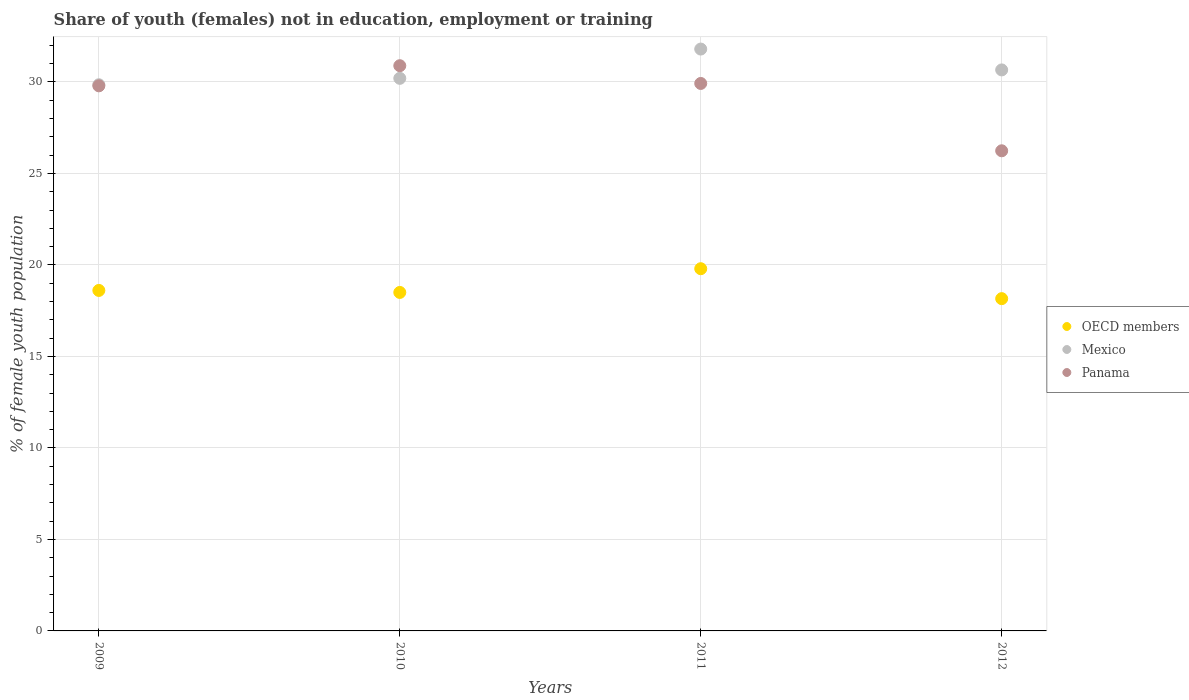Is the number of dotlines equal to the number of legend labels?
Offer a very short reply. Yes. What is the percentage of unemployed female population in in Mexico in 2012?
Provide a short and direct response. 30.66. Across all years, what is the maximum percentage of unemployed female population in in OECD members?
Your answer should be compact. 19.8. Across all years, what is the minimum percentage of unemployed female population in in Mexico?
Your answer should be compact. 29.85. In which year was the percentage of unemployed female population in in Mexico maximum?
Offer a very short reply. 2011. What is the total percentage of unemployed female population in in Panama in the graph?
Your answer should be very brief. 116.84. What is the difference between the percentage of unemployed female population in in Mexico in 2009 and that in 2011?
Offer a very short reply. -1.95. What is the difference between the percentage of unemployed female population in in Panama in 2009 and the percentage of unemployed female population in in Mexico in 2010?
Give a very brief answer. -0.41. What is the average percentage of unemployed female population in in OECD members per year?
Make the answer very short. 18.77. In the year 2010, what is the difference between the percentage of unemployed female population in in Mexico and percentage of unemployed female population in in OECD members?
Your answer should be compact. 11.7. What is the ratio of the percentage of unemployed female population in in OECD members in 2009 to that in 2011?
Ensure brevity in your answer.  0.94. Is the percentage of unemployed female population in in OECD members in 2009 less than that in 2012?
Ensure brevity in your answer.  No. What is the difference between the highest and the second highest percentage of unemployed female population in in Panama?
Offer a very short reply. 0.97. What is the difference between the highest and the lowest percentage of unemployed female population in in Mexico?
Offer a very short reply. 1.95. How many dotlines are there?
Your answer should be compact. 3. What is the difference between two consecutive major ticks on the Y-axis?
Your response must be concise. 5. Are the values on the major ticks of Y-axis written in scientific E-notation?
Make the answer very short. No. Where does the legend appear in the graph?
Your answer should be compact. Center right. What is the title of the graph?
Make the answer very short. Share of youth (females) not in education, employment or training. Does "Qatar" appear as one of the legend labels in the graph?
Provide a short and direct response. No. What is the label or title of the Y-axis?
Ensure brevity in your answer.  % of female youth population. What is the % of female youth population in OECD members in 2009?
Ensure brevity in your answer.  18.61. What is the % of female youth population in Mexico in 2009?
Your answer should be very brief. 29.85. What is the % of female youth population in Panama in 2009?
Give a very brief answer. 29.79. What is the % of female youth population of OECD members in 2010?
Offer a terse response. 18.5. What is the % of female youth population of Mexico in 2010?
Keep it short and to the point. 30.2. What is the % of female youth population in Panama in 2010?
Your answer should be compact. 30.89. What is the % of female youth population in OECD members in 2011?
Provide a succinct answer. 19.8. What is the % of female youth population in Mexico in 2011?
Provide a short and direct response. 31.8. What is the % of female youth population of Panama in 2011?
Offer a very short reply. 29.92. What is the % of female youth population in OECD members in 2012?
Provide a short and direct response. 18.16. What is the % of female youth population in Mexico in 2012?
Provide a short and direct response. 30.66. What is the % of female youth population of Panama in 2012?
Offer a very short reply. 26.24. Across all years, what is the maximum % of female youth population of OECD members?
Your answer should be compact. 19.8. Across all years, what is the maximum % of female youth population of Mexico?
Your answer should be compact. 31.8. Across all years, what is the maximum % of female youth population of Panama?
Your answer should be very brief. 30.89. Across all years, what is the minimum % of female youth population in OECD members?
Offer a terse response. 18.16. Across all years, what is the minimum % of female youth population of Mexico?
Your answer should be very brief. 29.85. Across all years, what is the minimum % of female youth population in Panama?
Your answer should be compact. 26.24. What is the total % of female youth population of OECD members in the graph?
Make the answer very short. 75.06. What is the total % of female youth population of Mexico in the graph?
Ensure brevity in your answer.  122.51. What is the total % of female youth population in Panama in the graph?
Offer a terse response. 116.84. What is the difference between the % of female youth population of OECD members in 2009 and that in 2010?
Offer a very short reply. 0.11. What is the difference between the % of female youth population of Mexico in 2009 and that in 2010?
Provide a succinct answer. -0.35. What is the difference between the % of female youth population of OECD members in 2009 and that in 2011?
Your answer should be compact. -1.19. What is the difference between the % of female youth population of Mexico in 2009 and that in 2011?
Your response must be concise. -1.95. What is the difference between the % of female youth population of Panama in 2009 and that in 2011?
Make the answer very short. -0.13. What is the difference between the % of female youth population of OECD members in 2009 and that in 2012?
Ensure brevity in your answer.  0.45. What is the difference between the % of female youth population of Mexico in 2009 and that in 2012?
Give a very brief answer. -0.81. What is the difference between the % of female youth population in Panama in 2009 and that in 2012?
Make the answer very short. 3.55. What is the difference between the % of female youth population of OECD members in 2010 and that in 2011?
Your answer should be compact. -1.3. What is the difference between the % of female youth population of OECD members in 2010 and that in 2012?
Keep it short and to the point. 0.34. What is the difference between the % of female youth population of Mexico in 2010 and that in 2012?
Give a very brief answer. -0.46. What is the difference between the % of female youth population of Panama in 2010 and that in 2012?
Make the answer very short. 4.65. What is the difference between the % of female youth population of OECD members in 2011 and that in 2012?
Offer a very short reply. 1.64. What is the difference between the % of female youth population of Mexico in 2011 and that in 2012?
Your answer should be very brief. 1.14. What is the difference between the % of female youth population of Panama in 2011 and that in 2012?
Keep it short and to the point. 3.68. What is the difference between the % of female youth population of OECD members in 2009 and the % of female youth population of Mexico in 2010?
Your answer should be very brief. -11.59. What is the difference between the % of female youth population of OECD members in 2009 and the % of female youth population of Panama in 2010?
Your answer should be very brief. -12.28. What is the difference between the % of female youth population of Mexico in 2009 and the % of female youth population of Panama in 2010?
Your answer should be compact. -1.04. What is the difference between the % of female youth population in OECD members in 2009 and the % of female youth population in Mexico in 2011?
Ensure brevity in your answer.  -13.19. What is the difference between the % of female youth population in OECD members in 2009 and the % of female youth population in Panama in 2011?
Your response must be concise. -11.31. What is the difference between the % of female youth population in Mexico in 2009 and the % of female youth population in Panama in 2011?
Give a very brief answer. -0.07. What is the difference between the % of female youth population in OECD members in 2009 and the % of female youth population in Mexico in 2012?
Your response must be concise. -12.05. What is the difference between the % of female youth population in OECD members in 2009 and the % of female youth population in Panama in 2012?
Keep it short and to the point. -7.63. What is the difference between the % of female youth population in Mexico in 2009 and the % of female youth population in Panama in 2012?
Your answer should be compact. 3.61. What is the difference between the % of female youth population of OECD members in 2010 and the % of female youth population of Mexico in 2011?
Provide a short and direct response. -13.3. What is the difference between the % of female youth population in OECD members in 2010 and the % of female youth population in Panama in 2011?
Give a very brief answer. -11.42. What is the difference between the % of female youth population in Mexico in 2010 and the % of female youth population in Panama in 2011?
Provide a short and direct response. 0.28. What is the difference between the % of female youth population of OECD members in 2010 and the % of female youth population of Mexico in 2012?
Offer a terse response. -12.16. What is the difference between the % of female youth population of OECD members in 2010 and the % of female youth population of Panama in 2012?
Give a very brief answer. -7.74. What is the difference between the % of female youth population in Mexico in 2010 and the % of female youth population in Panama in 2012?
Provide a succinct answer. 3.96. What is the difference between the % of female youth population of OECD members in 2011 and the % of female youth population of Mexico in 2012?
Offer a terse response. -10.86. What is the difference between the % of female youth population of OECD members in 2011 and the % of female youth population of Panama in 2012?
Offer a terse response. -6.44. What is the difference between the % of female youth population in Mexico in 2011 and the % of female youth population in Panama in 2012?
Give a very brief answer. 5.56. What is the average % of female youth population in OECD members per year?
Offer a terse response. 18.77. What is the average % of female youth population of Mexico per year?
Give a very brief answer. 30.63. What is the average % of female youth population in Panama per year?
Make the answer very short. 29.21. In the year 2009, what is the difference between the % of female youth population in OECD members and % of female youth population in Mexico?
Your answer should be compact. -11.24. In the year 2009, what is the difference between the % of female youth population of OECD members and % of female youth population of Panama?
Your answer should be very brief. -11.18. In the year 2010, what is the difference between the % of female youth population in OECD members and % of female youth population in Mexico?
Offer a very short reply. -11.7. In the year 2010, what is the difference between the % of female youth population in OECD members and % of female youth population in Panama?
Your answer should be very brief. -12.39. In the year 2010, what is the difference between the % of female youth population of Mexico and % of female youth population of Panama?
Your response must be concise. -0.69. In the year 2011, what is the difference between the % of female youth population in OECD members and % of female youth population in Mexico?
Provide a succinct answer. -12. In the year 2011, what is the difference between the % of female youth population in OECD members and % of female youth population in Panama?
Offer a very short reply. -10.12. In the year 2011, what is the difference between the % of female youth population in Mexico and % of female youth population in Panama?
Keep it short and to the point. 1.88. In the year 2012, what is the difference between the % of female youth population in OECD members and % of female youth population in Mexico?
Give a very brief answer. -12.5. In the year 2012, what is the difference between the % of female youth population of OECD members and % of female youth population of Panama?
Your answer should be compact. -8.08. In the year 2012, what is the difference between the % of female youth population of Mexico and % of female youth population of Panama?
Provide a succinct answer. 4.42. What is the ratio of the % of female youth population in OECD members in 2009 to that in 2010?
Provide a short and direct response. 1.01. What is the ratio of the % of female youth population of Mexico in 2009 to that in 2010?
Provide a succinct answer. 0.99. What is the ratio of the % of female youth population in Panama in 2009 to that in 2010?
Your answer should be compact. 0.96. What is the ratio of the % of female youth population in OECD members in 2009 to that in 2011?
Your answer should be compact. 0.94. What is the ratio of the % of female youth population in Mexico in 2009 to that in 2011?
Your answer should be very brief. 0.94. What is the ratio of the % of female youth population in OECD members in 2009 to that in 2012?
Ensure brevity in your answer.  1.02. What is the ratio of the % of female youth population of Mexico in 2009 to that in 2012?
Keep it short and to the point. 0.97. What is the ratio of the % of female youth population in Panama in 2009 to that in 2012?
Give a very brief answer. 1.14. What is the ratio of the % of female youth population of OECD members in 2010 to that in 2011?
Give a very brief answer. 0.93. What is the ratio of the % of female youth population of Mexico in 2010 to that in 2011?
Give a very brief answer. 0.95. What is the ratio of the % of female youth population in Panama in 2010 to that in 2011?
Your answer should be compact. 1.03. What is the ratio of the % of female youth population of OECD members in 2010 to that in 2012?
Provide a succinct answer. 1.02. What is the ratio of the % of female youth population of Panama in 2010 to that in 2012?
Your answer should be very brief. 1.18. What is the ratio of the % of female youth population of OECD members in 2011 to that in 2012?
Ensure brevity in your answer.  1.09. What is the ratio of the % of female youth population of Mexico in 2011 to that in 2012?
Offer a very short reply. 1.04. What is the ratio of the % of female youth population of Panama in 2011 to that in 2012?
Keep it short and to the point. 1.14. What is the difference between the highest and the second highest % of female youth population in OECD members?
Your response must be concise. 1.19. What is the difference between the highest and the second highest % of female youth population in Mexico?
Make the answer very short. 1.14. What is the difference between the highest and the second highest % of female youth population of Panama?
Keep it short and to the point. 0.97. What is the difference between the highest and the lowest % of female youth population in OECD members?
Provide a short and direct response. 1.64. What is the difference between the highest and the lowest % of female youth population of Mexico?
Your response must be concise. 1.95. What is the difference between the highest and the lowest % of female youth population in Panama?
Provide a succinct answer. 4.65. 